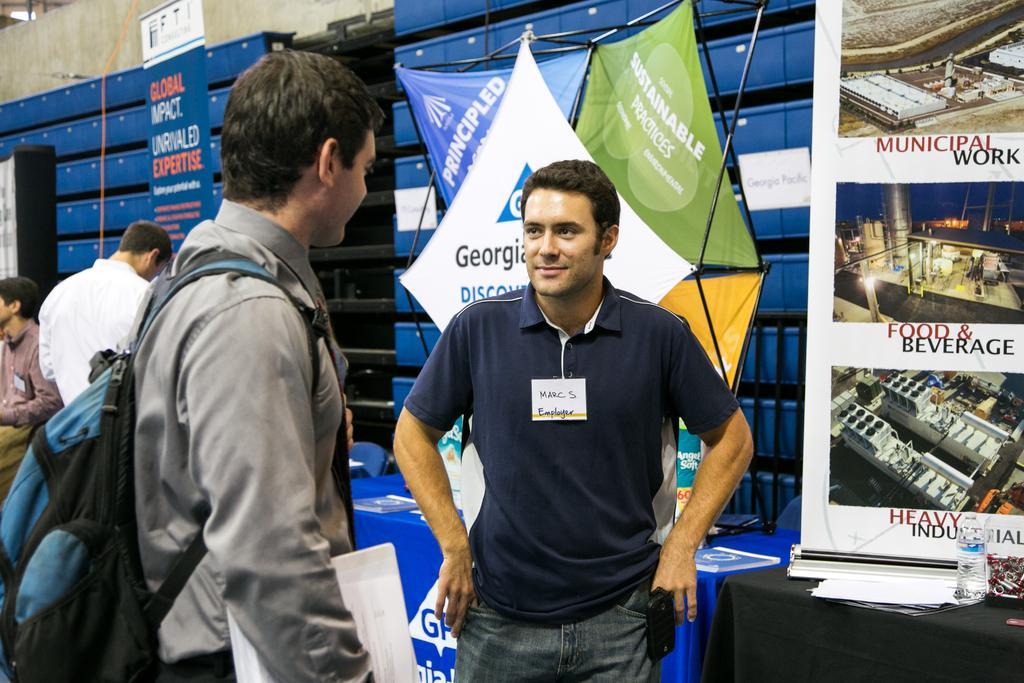Can you describe this image briefly? In this picture on the left corner, we see a man in grey shirt is wearing blue and black color backpack is holding some papers in her hand in his hands. The man in the middle wearing blue t-shirt, is having a badge with his name on it. He is looking to the man and smiling. Beside him, we see a table on which black color cloth is placed and on the table, we see papers and water bottle. Behind that, we see banner with some images and text written on it. Behind this man, we see some banners and also some books which are blue in color. 